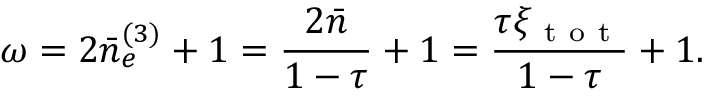<formula> <loc_0><loc_0><loc_500><loc_500>\omega = 2 \bar { n } _ { e } ^ { ( 3 ) } + 1 = \frac { 2 \bar { n } } { 1 - \tau } + 1 = \frac { \tau \xi _ { t o t } } { 1 - \tau } + 1 .</formula> 